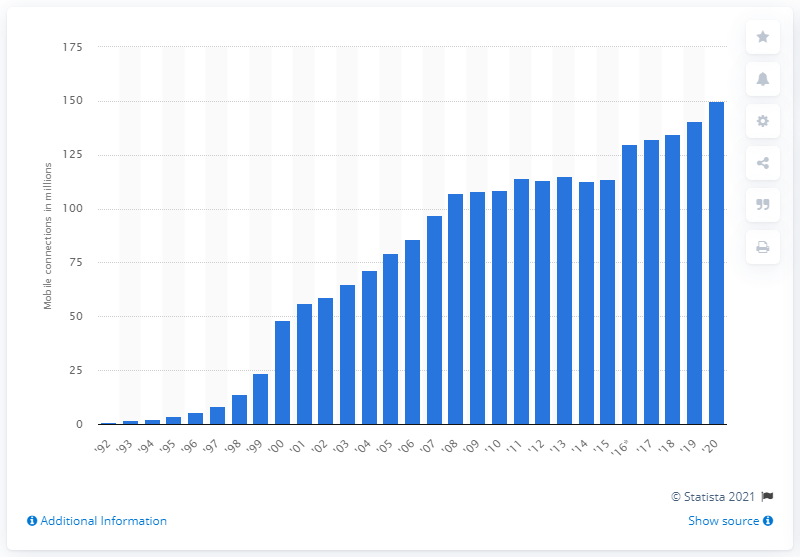Highlight a few significant elements in this photo. In 2020, there were 150 million mobile connections in Germany. 